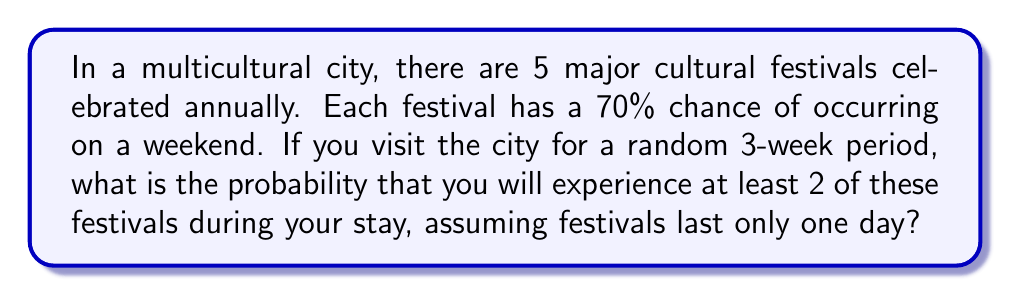Solve this math problem. Let's approach this step-by-step:

1) First, we need to calculate the probability of a festival occurring during your 3-week stay:
   - 3 weeks = 21 days
   - Probability of occurring on a weekend = 0.7
   - Probability of occurring during your stay = $21/365 * 0.7 = 0.0403$

2) Let $p = 0.0403$ be the probability of a festival occurring during your stay.

3) We can use the complement of the binomial distribution to solve this. We want the probability of at least 2 successes, which is equal to 1 minus the probability of 0 or 1 success.

4) The probability of exactly $k$ successes in $n$ trials is given by the binomial probability formula:

   $P(X = k) = \binom{n}{k} p^k (1-p)^{n-k}$

5) Therefore, the probability of at least 2 successes is:

   $P(X \geq 2) = 1 - [P(X = 0) + P(X = 1)]$

6) Let's calculate each part:
   
   $P(X = 0) = \binom{5}{0} (0.0403)^0 (0.9597)^5 = 0.8145$
   
   $P(X = 1) = \binom{5}{1} (0.0403)^1 (0.9597)^4 = 0.1697$

7) Now, we can put it all together:

   $P(X \geq 2) = 1 - (0.8145 + 0.1697) = 1 - 0.9842 = 0.0158$

Therefore, the probability of experiencing at least 2 festivals during your 3-week stay is approximately 0.0158 or 1.58%.
Answer: $0.0158$ or $1.58\%$ 